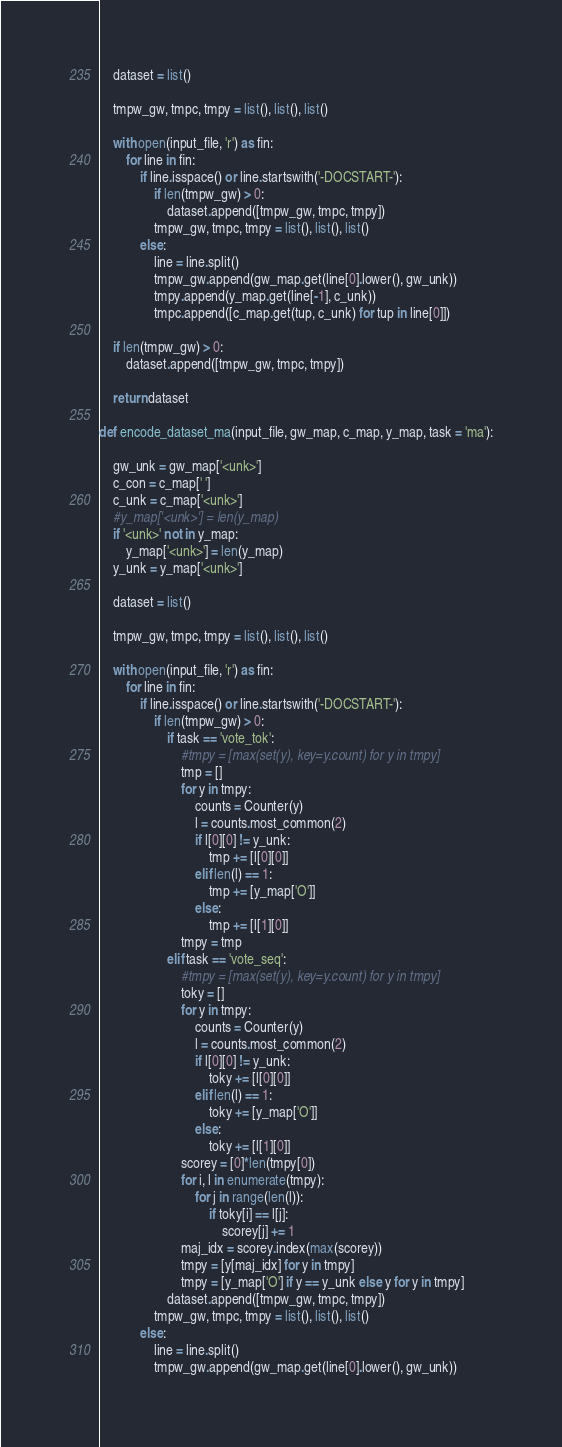Convert code to text. <code><loc_0><loc_0><loc_500><loc_500><_Python_>    dataset = list()

    tmpw_gw, tmpc, tmpy = list(), list(), list()

    with open(input_file, 'r') as fin:
        for line in fin:
            if line.isspace() or line.startswith('-DOCSTART-'):
                if len(tmpw_gw) > 0:
                    dataset.append([tmpw_gw, tmpc, tmpy])
                tmpw_gw, tmpc, tmpy = list(), list(), list()
            else:
                line = line.split()
                tmpw_gw.append(gw_map.get(line[0].lower(), gw_unk))
                tmpy.append(y_map.get(line[-1], c_unk))
                tmpc.append([c_map.get(tup, c_unk) for tup in line[0]])

    if len(tmpw_gw) > 0:
        dataset.append([tmpw_gw, tmpc, tmpy])

    return dataset

def encode_dataset_ma(input_file, gw_map, c_map, y_map, task = 'ma'):

    gw_unk = gw_map['<unk>']
    c_con = c_map[' ']
    c_unk = c_map['<unk>']
    #y_map['<unk>'] = len(y_map)
    if '<unk>' not in y_map:
        y_map['<unk>'] = len(y_map)
    y_unk = y_map['<unk>']

    dataset = list()

    tmpw_gw, tmpc, tmpy = list(), list(), list()

    with open(input_file, 'r') as fin:
        for line in fin:
            if line.isspace() or line.startswith('-DOCSTART-'):
                if len(tmpw_gw) > 0:
                    if task == 'vote_tok':
                        #tmpy = [max(set(y), key=y.count) for y in tmpy]    
                        tmp = []
                        for y in tmpy:
                            counts = Counter(y)
                            l = counts.most_common(2)
                            if l[0][0] != y_unk:
                                tmp += [l[0][0]]
                            elif len(l) == 1:
                                tmp += [y_map['O']]
                            else:
                                tmp += [l[1][0]]
                        tmpy = tmp
                    elif task == 'vote_seq':
                        #tmpy = [max(set(y), key=y.count) for y in tmpy]
                        toky = []
                        for y in tmpy:
                            counts = Counter(y)
                            l = counts.most_common(2)
                            if l[0][0] != y_unk:
                                toky += [l[0][0]]
                            elif len(l) == 1:
                                toky += [y_map['O']]
                            else:
                                toky += [l[1][0]]
                        scorey = [0]*len(tmpy[0])
                        for i, l in enumerate(tmpy):
                            for j in range(len(l)):
                                if toky[i] == l[j]:
                                    scorey[j] += 1
                        maj_idx = scorey.index(max(scorey))
                        tmpy = [y[maj_idx] for y in tmpy]
                        tmpy = [y_map['O'] if y == y_unk else y for y in tmpy]
                    dataset.append([tmpw_gw, tmpc, tmpy])
                tmpw_gw, tmpc, tmpy = list(), list(), list()
            else:
                line = line.split()
                tmpw_gw.append(gw_map.get(line[0].lower(), gw_unk))</code> 